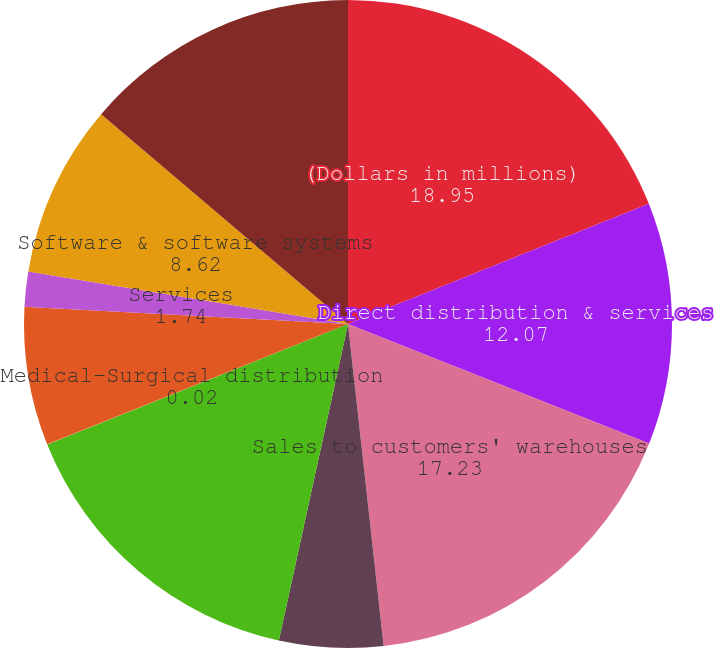Convert chart to OTSL. <chart><loc_0><loc_0><loc_500><loc_500><pie_chart><fcel>(Dollars in millions)<fcel>Direct distribution & services<fcel>Sales to customers' warehouses<fcel>Total US pharmaceutical<fcel>Canada pharmaceutical<fcel>Medical-Surgical distribution<fcel>Total Distribution Solutions<fcel>Services<fcel>Software & software systems<fcel>Hardware<nl><fcel>18.95%<fcel>12.07%<fcel>17.23%<fcel>5.18%<fcel>15.51%<fcel>0.02%<fcel>6.9%<fcel>1.74%<fcel>8.62%<fcel>13.79%<nl></chart> 